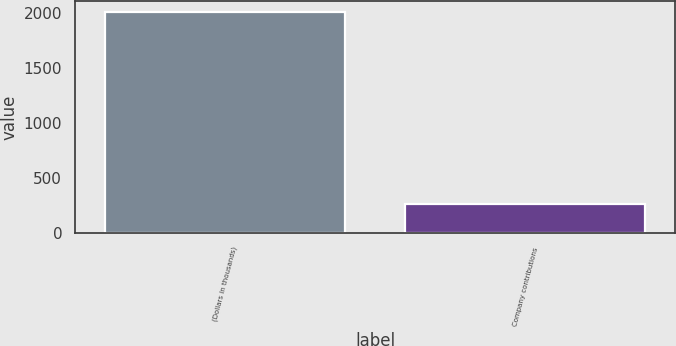Convert chart to OTSL. <chart><loc_0><loc_0><loc_500><loc_500><bar_chart><fcel>(Dollars in thousands)<fcel>Company contributions<nl><fcel>2012<fcel>267<nl></chart> 